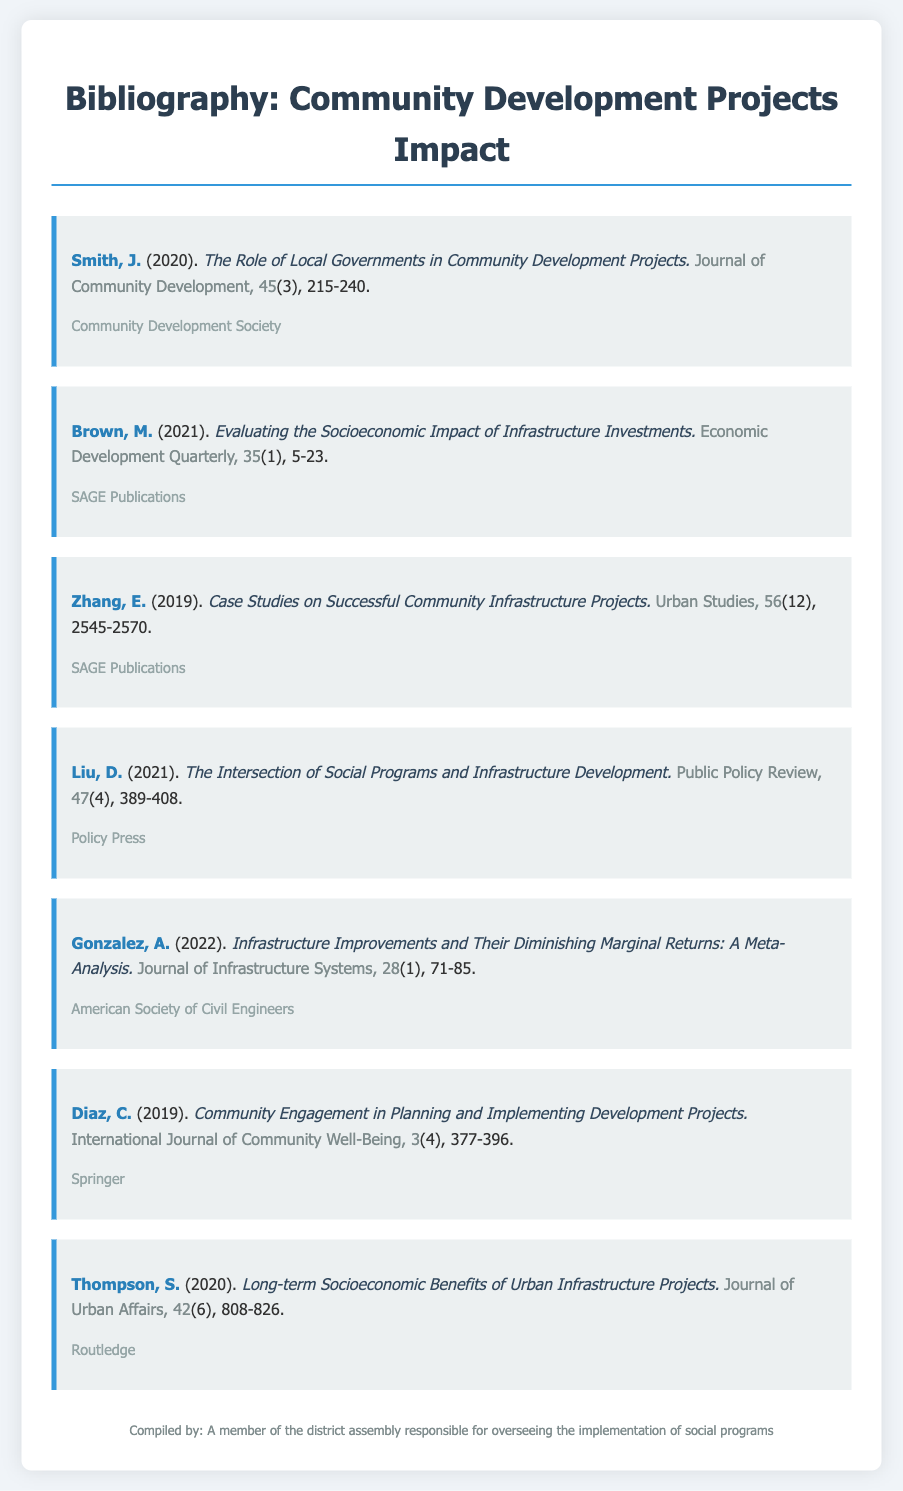What is the title of Smith's publication? The title is listed directly under the author's name in the bibliography item for Smith, J.
Answer: The Role of Local Governments in Community Development Projects What year was Brown's article published? The publication year is included in parentheses after the author's name.
Answer: 2021 Which journal published the article by Gonzalez? The journal name is identified after the title of Gonzalez's work.
Answer: Journal of Infrastructure Systems How many pages does Liu's article cover? The page range is indicated at the end of Liu's entry in the bibliography.
Answer: 389-408 What is the main focus of Diaz's research? The focus of the research is reflected in the title of Diaz's entry.
Answer: Community Engagement in Planning and Implementing Development Projects Who is the author of the meta-analysis on infrastructure improvements? The author's name appears prominently at the beginning of the corresponding bibliography item.
Answer: Gonzalez, A What volume number is associated with the article by Zhang? The volume number is part of the bibliographic details provided for Zhang's article.
Answer: 56 What type of publication are all entries found in this document? The nature of the document is indicated by the title and structure of the content presented.
Answer: Bibliography 